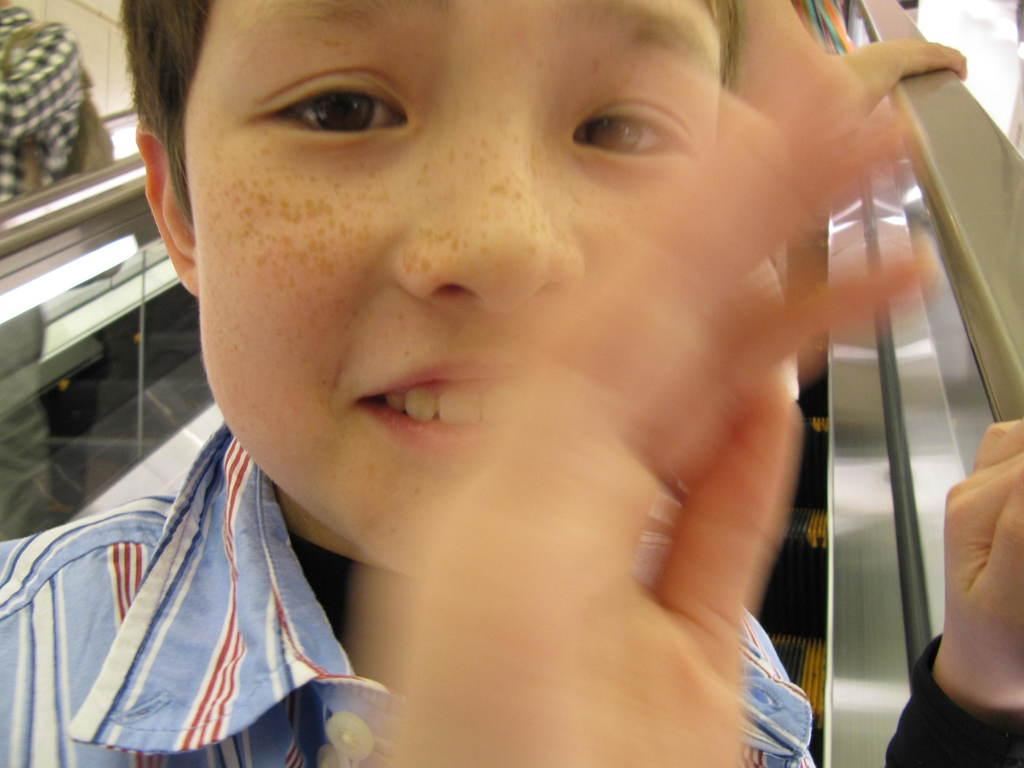Who or what can be seen in the image? There are people in the image. What are the people doing in the image? The people are on an escalator. What type of yarn is being used by the people on the escalator? There is no yarn present in the image; the people are simply riding an escalator. 